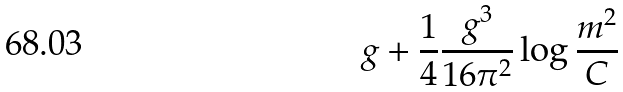<formula> <loc_0><loc_0><loc_500><loc_500>g + \frac { 1 } { 4 } \frac { g ^ { 3 } } { 1 6 \pi ^ { 2 } } \log \frac { m ^ { 2 } } { C }</formula> 